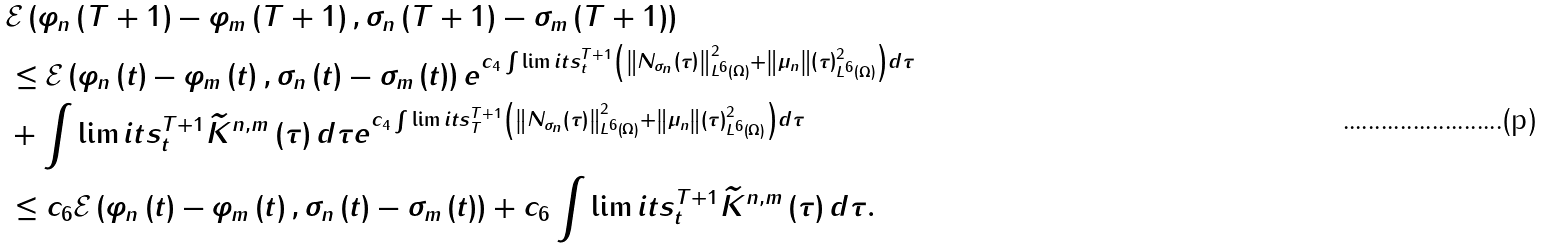Convert formula to latex. <formula><loc_0><loc_0><loc_500><loc_500>& \mathcal { E } \left ( \varphi _ { n } \left ( T + 1 \right ) - \varphi _ { m } \left ( T + 1 \right ) , \sigma _ { n } \left ( T + 1 \right ) - \sigma _ { m } \left ( T + 1 \right ) \right ) \\ & \leq \mathcal { E } \left ( \varphi _ { n } \left ( t \right ) - \varphi _ { m } \left ( t \right ) , \sigma _ { n } \left ( t \right ) - \sigma _ { m } \left ( t \right ) \right ) e ^ { c _ { 4 } \int \lim i t s _ { t } ^ { T + 1 } \left ( \left \| N _ { \sigma _ { n } } \left ( \tau \right ) \right \| _ { L ^ { 6 } \left ( \Omega \right ) } ^ { 2 } + \left \| \mu _ { n } \right \| \left ( \tau \right ) _ { L ^ { 6 } \left ( \Omega \right ) } ^ { 2 } \right ) d \tau } \\ & + \int \lim i t s _ { t } ^ { T + 1 } \widetilde { K } ^ { n , m } \left ( \tau \right ) d \tau e ^ { c _ { 4 } \int \lim i t s _ { T } ^ { T + 1 } \left ( \left \| N _ { \sigma _ { n } } \left ( \tau \right ) \right \| _ { L ^ { 6 } \left ( \Omega \right ) } ^ { 2 } + \left \| \mu _ { n } \right \| \left ( \tau \right ) _ { L ^ { 6 } \left ( \Omega \right ) } ^ { 2 } \right ) d \tau } \\ & \leq c _ { 6 } \mathcal { E } \left ( \varphi _ { n } \left ( t \right ) - \varphi _ { m } \left ( t \right ) , \sigma _ { n } \left ( t \right ) - \sigma _ { m } \left ( t \right ) \right ) + c _ { 6 } \int \lim i t s _ { t } ^ { T + 1 } \widetilde { K } ^ { n , m } \left ( \tau \right ) d \tau .</formula> 